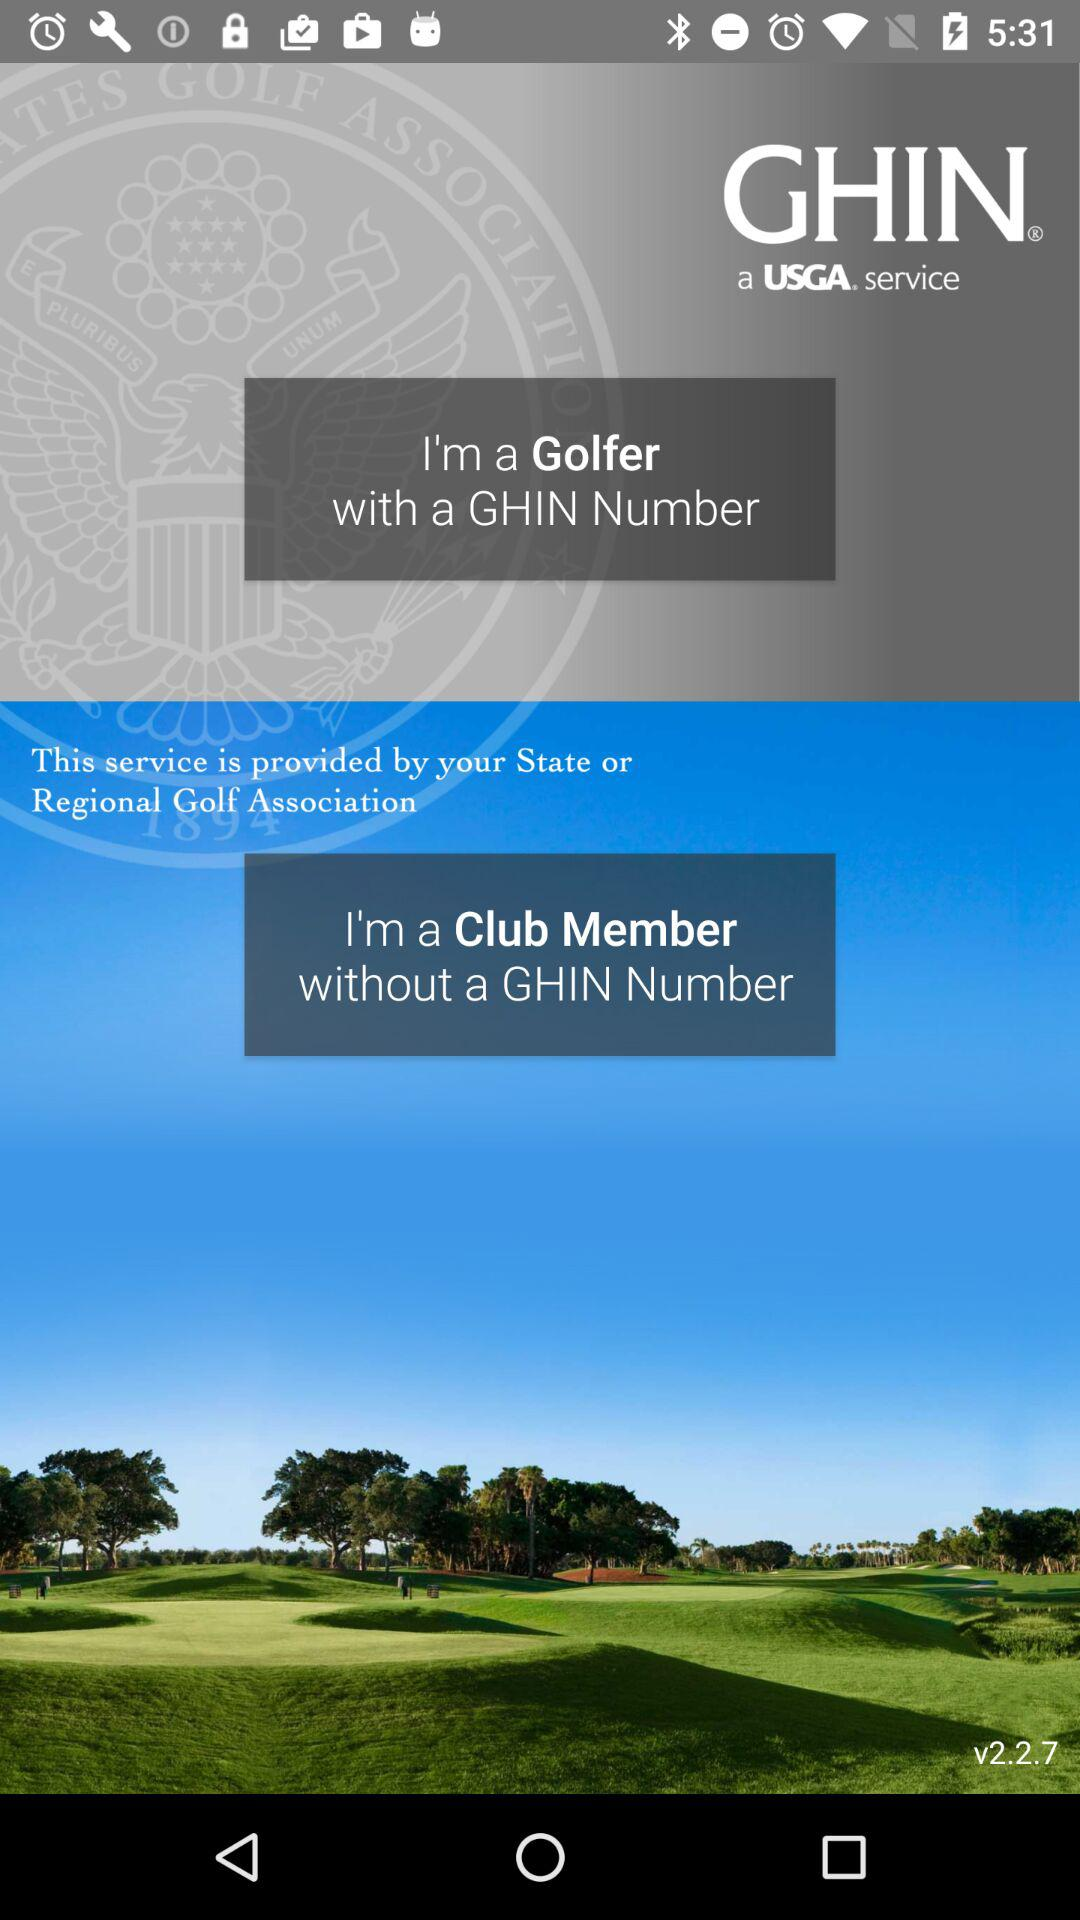What is the name of the application? The name of the application is "GHIN". 